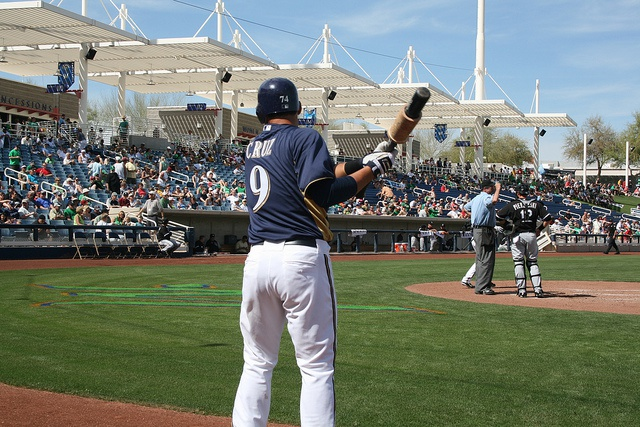Describe the objects in this image and their specific colors. I can see people in lightblue, black, gray, darkgray, and lightgray tones, people in lightblue, lavender, black, gray, and darkgray tones, chair in lightblue, black, navy, gray, and blue tones, people in lightblue, black, gray, lightgray, and darkgray tones, and people in lightblue, black, and gray tones in this image. 